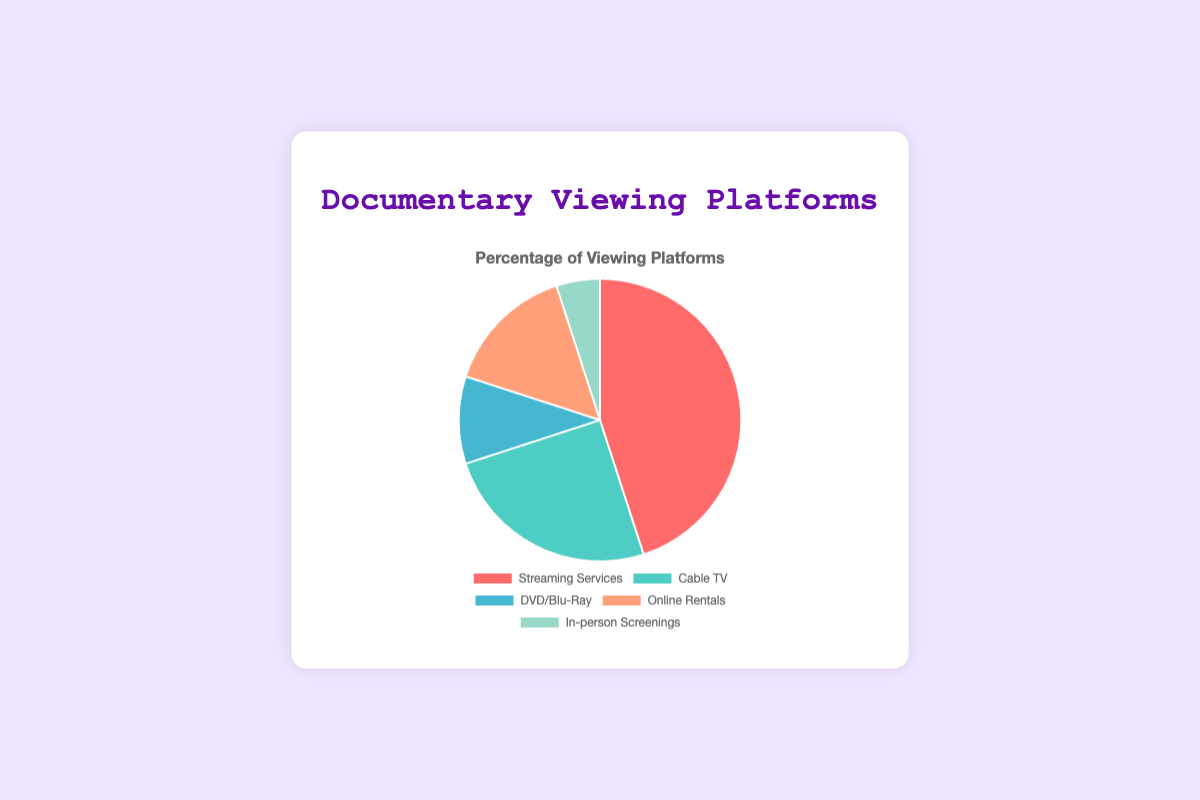What percentage of people watch documentaries on Cable TV? The pie chart shows that 25% of people watch documentaries on Cable TV.
Answer: 25% Do more people watch documentaries on Online Rentals or DVD/Blu-Ray? The pie chart shows that 15% of people watch documentaries via Online Rentals, whereas 10% use DVD/Blu-Ray. 15% is greater than 10%.
Answer: Online Rentals What is the total percentage of people who watch documentaries on Cable TV and In-person Screenings? The pie chart shows 25% for Cable TV and 5% for In-person Screenings. Adding these together gives 25% + 5% = 30%.
Answer: 30% Which viewing platform has the smallest percentage of users? The pie chart shows that In-person Screenings has a percentage of 5%, which is the smallest among the given platforms.
Answer: In-person Screenings How much more popular are Streaming Services compared to DVD/Blu-Ray? Streaming Services have a percentage of 45%, while DVD/Blu-Ray have 10%. The difference is 45% - 10% = 35%.
Answer: 35% What is the average percentage of users for Online Rentals and DVD/Blu-Ray combined? Online Rentals have 15% and DVD/Blu-Ray have 10%. Their average is (15% + 10%) / 2 = 25% / 2 = 12.5%.
Answer: 12.5% Identify the platform represented by the green-colored segment. The pie chart shows the colors for each platform, and the green segment corresponds to Cable TV.
Answer: Cable TV Which two platforms together make up half (50%) of the viewing preferences? Streaming Services have 45% and Cable TV has 25%. Together they sum to 45% + 25% = 70%, which is greater than 50%. The next viable combination is Streaming Services (45%) and Online Rentals (15%), combined they make 45% + 15% = 60%. Hence, no two platforms exactly make 50%, but Streaming Services and Online Rentals are close.
Answer: Streaming Services and Online Rentals What's the difference in percentage between the most and least popular platforms? The most popular platform is Streaming Services with 45%, and the least popular is In-person Screenings with 5%. The difference is 45% - 5% = 40%.
Answer: 40% If you were to merge DVD/Blu-Ray and Online Rentals into a single category, what would their combined percentage be? DVD/Blu-Ray has 10% and Online Rentals have 15%. Combined, they would have 10% + 15% = 25%.
Answer: 25% 